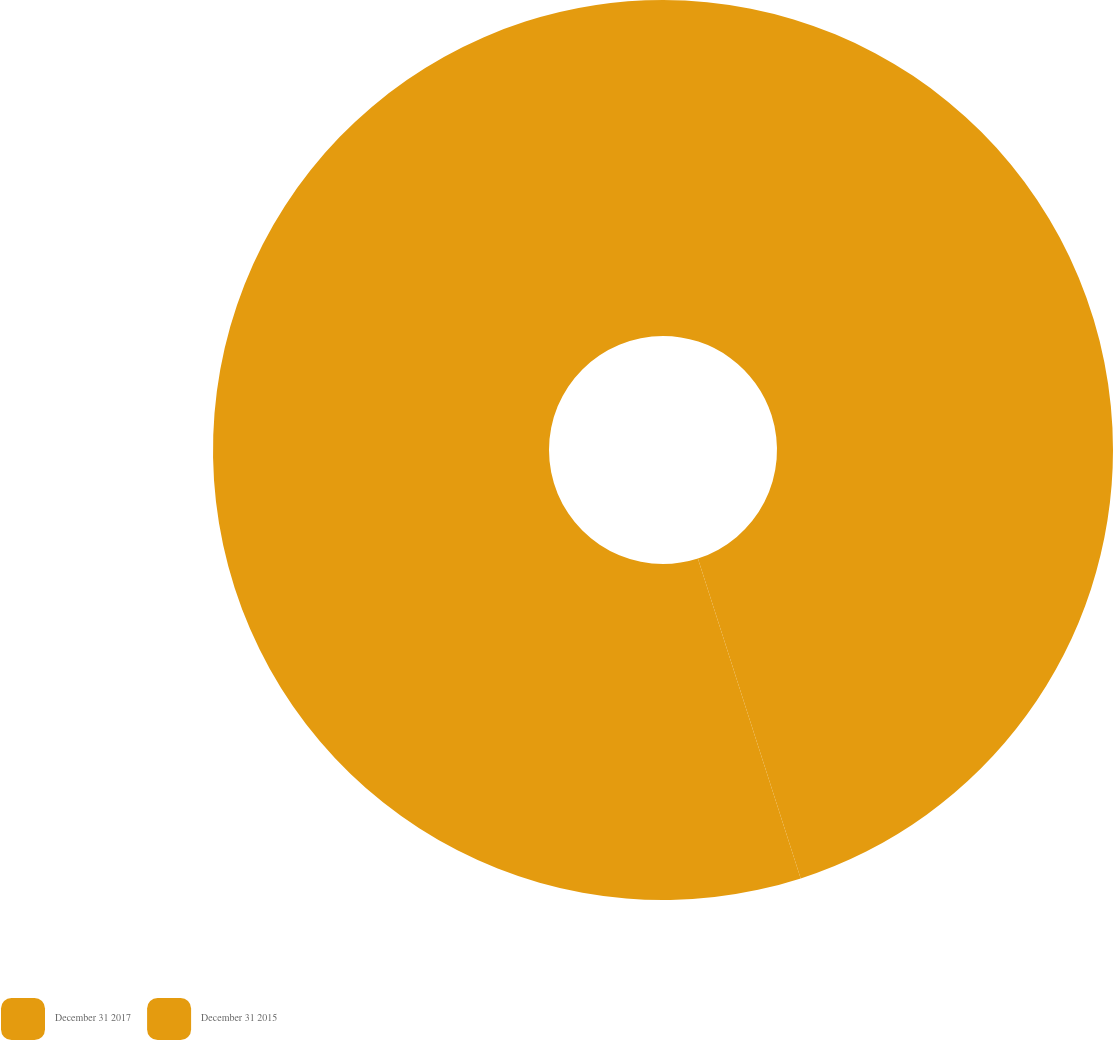<chart> <loc_0><loc_0><loc_500><loc_500><pie_chart><fcel>December 31 2017<fcel>December 31 2015<nl><fcel>45.05%<fcel>54.95%<nl></chart> 